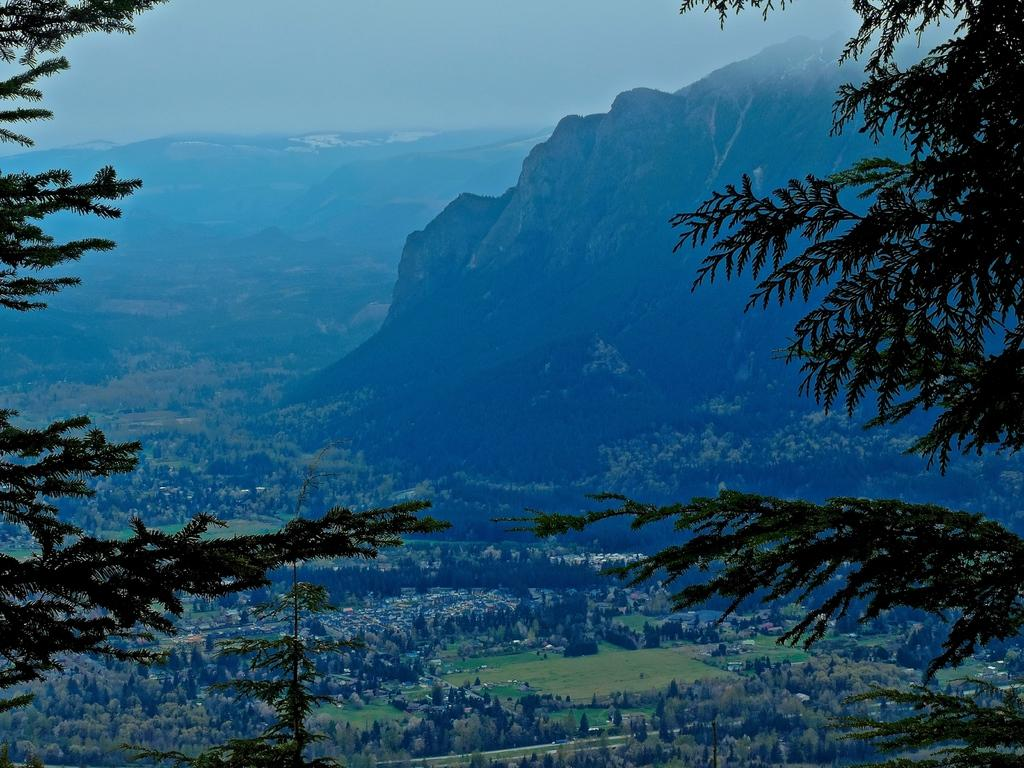What type of vegetation is present in the image? There are trees in the image, both in the front and background. What natural feature can be seen in the distance? Mountains are visible in the background of the image. What color is the sky in the middle of the image? There is no sky present in the middle of the image; it is only visible in the background. 